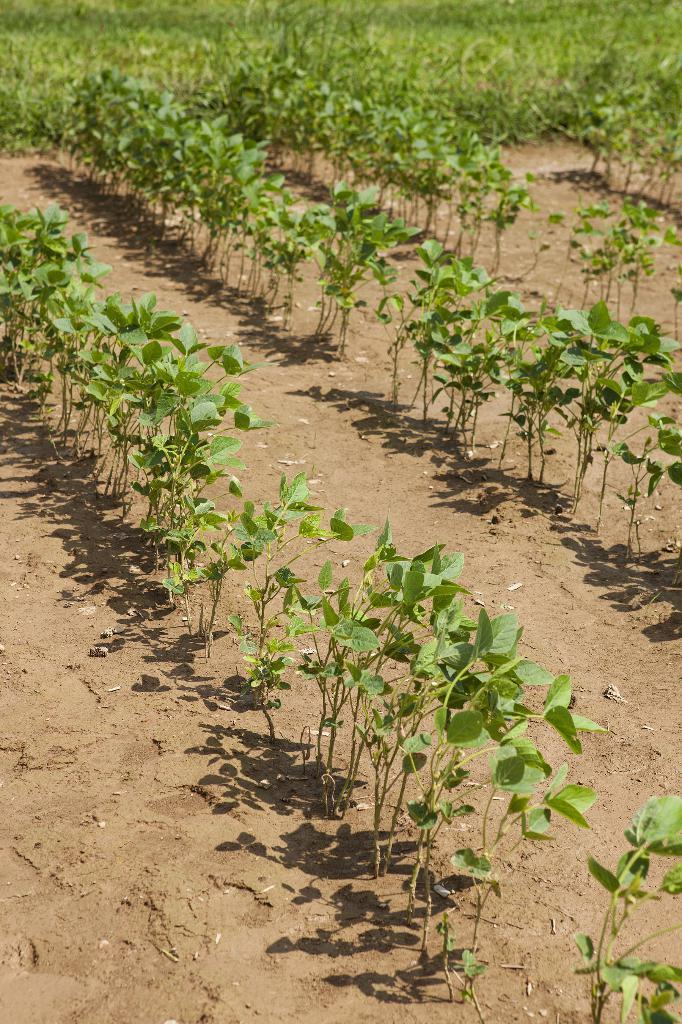What type of living organisms can be seen in the image? Plants can be seen in the image. What part of the plants is visible in the image? The plants have leaves in the image. What color are the leaves of the plants? The leaves are green in color. How many cakes are displayed on the receipt in the image? There are no cakes or receipts present in the image; it features plants with green leaves. How many cats can be seen playing with the leaves in the image? There are no cats present in the image; it features plants with green leaves. 